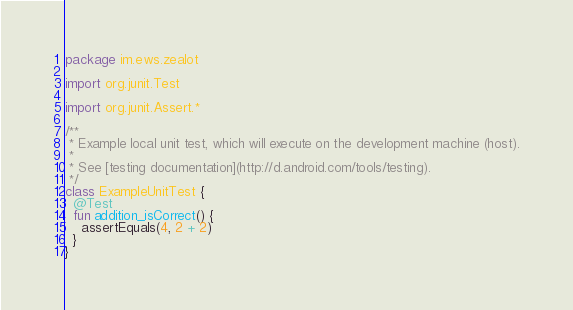<code> <loc_0><loc_0><loc_500><loc_500><_Kotlin_>package im.ews.zealot

import org.junit.Test

import org.junit.Assert.*

/**
 * Example local unit test, which will execute on the development machine (host).
 *
 * See [testing documentation](http://d.android.com/tools/testing).
 */
class ExampleUnitTest {
  @Test
  fun addition_isCorrect() {
    assertEquals(4, 2 + 2)
  }
}
</code> 